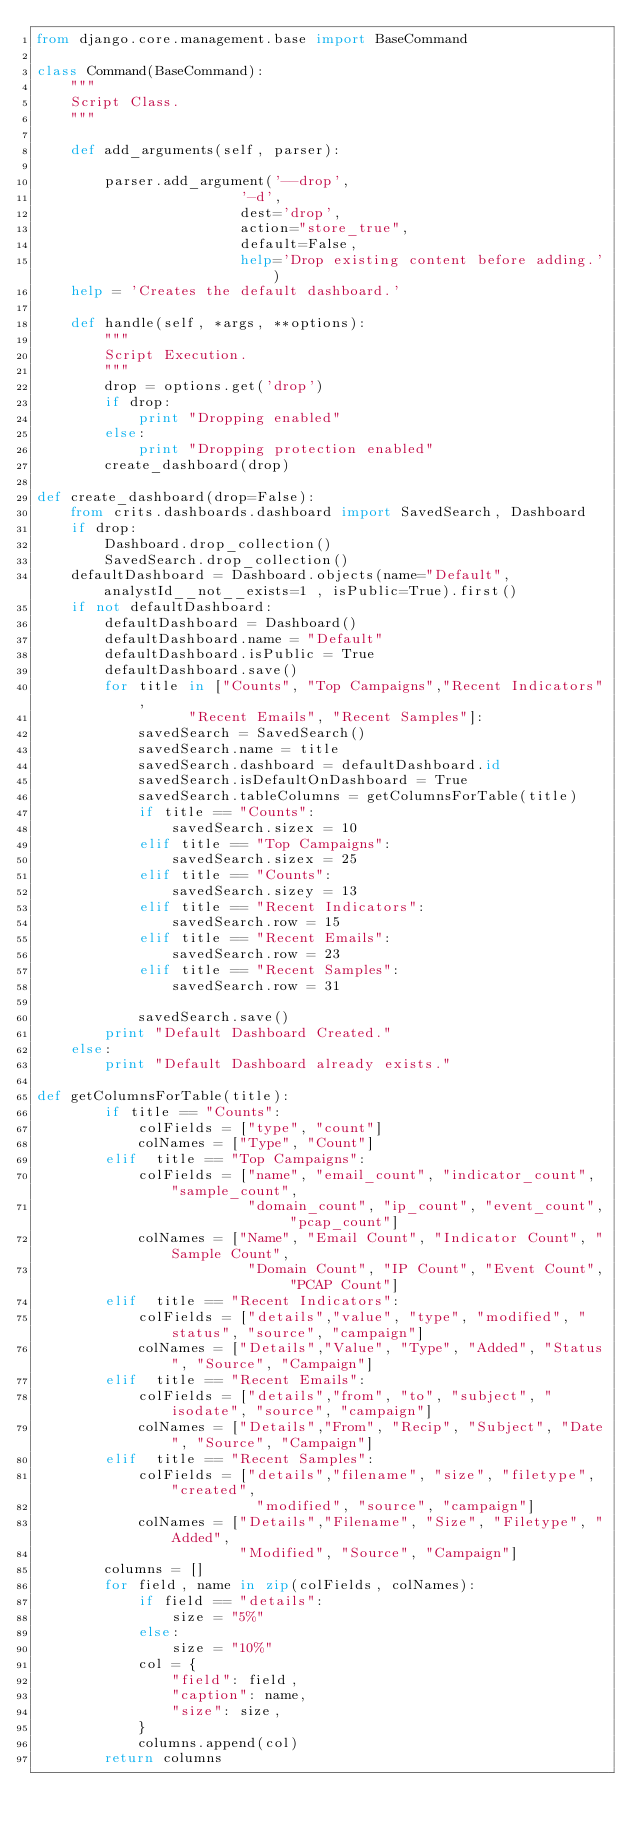Convert code to text. <code><loc_0><loc_0><loc_500><loc_500><_Python_>from django.core.management.base import BaseCommand

class Command(BaseCommand):
    """
    Script Class.
    """

    def add_arguments(self, parser):

        parser.add_argument('--drop',
                        '-d',
                        dest='drop',
                        action="store_true",
                        default=False,
                        help='Drop existing content before adding.')
    help = 'Creates the default dashboard.'

    def handle(self, *args, **options):
        """
        Script Execution.
        """
        drop = options.get('drop')
        if drop:
            print "Dropping enabled"
        else:
            print "Dropping protection enabled"
        create_dashboard(drop)

def create_dashboard(drop=False):
    from crits.dashboards.dashboard import SavedSearch, Dashboard
    if drop:
        Dashboard.drop_collection()
        SavedSearch.drop_collection()
    defaultDashboard = Dashboard.objects(name="Default", analystId__not__exists=1 , isPublic=True).first()
    if not defaultDashboard:
        defaultDashboard = Dashboard()
        defaultDashboard.name = "Default"
        defaultDashboard.isPublic = True
        defaultDashboard.save()
        for title in ["Counts", "Top Campaigns","Recent Indicators",
                  "Recent Emails", "Recent Samples"]:
            savedSearch = SavedSearch()
            savedSearch.name = title
            savedSearch.dashboard = defaultDashboard.id
            savedSearch.isDefaultOnDashboard = True
            savedSearch.tableColumns = getColumnsForTable(title)
            if title == "Counts":
                savedSearch.sizex = 10
            elif title == "Top Campaigns":
                savedSearch.sizex = 25
            elif title == "Counts":
                savedSearch.sizey = 13
            elif title == "Recent Indicators":
                savedSearch.row = 15
            elif title == "Recent Emails":
                savedSearch.row = 23
            elif title == "Recent Samples":
                savedSearch.row = 31
                
            savedSearch.save()
        print "Default Dashboard Created."
    else:
        print "Default Dashboard already exists."
    
def getColumnsForTable(title):
        if title == "Counts":
            colFields = ["type", "count"]
            colNames = ["Type", "Count"]
        elif  title == "Top Campaigns":
            colFields = ["name", "email_count", "indicator_count", "sample_count", 
                         "domain_count", "ip_count", "event_count", "pcap_count"]
            colNames = ["Name", "Email Count", "Indicator Count", "Sample Count", 
                         "Domain Count", "IP Count", "Event Count", "PCAP Count"]
        elif  title == "Recent Indicators":
            colFields = ["details","value", "type", "modified", "status", "source", "campaign"]
            colNames = ["Details","Value", "Type", "Added", "Status", "Source", "Campaign"]
        elif  title == "Recent Emails":
            colFields = ["details","from", "to", "subject", "isodate", "source", "campaign"]
            colNames = ["Details","From", "Recip", "Subject", "Date", "Source", "Campaign"]
        elif  title == "Recent Samples":
            colFields = ["details","filename", "size", "filetype", "created",
                          "modified", "source", "campaign"]
            colNames = ["Details","Filename", "Size", "Filetype", "Added",
                        "Modified", "Source", "Campaign"]
        columns = []
        for field, name in zip(colFields, colNames):
            if field == "details":
                size = "5%"
            else:
                size = "10%"
            col = {
                "field": field,
                "caption": name,
                "size": size,
            }
            columns.append(col)
        return columns
</code> 